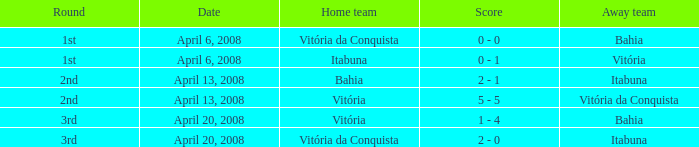What is the name of the home team with a round of 2nd and Vitória da Conquista as the way team? Vitória. 